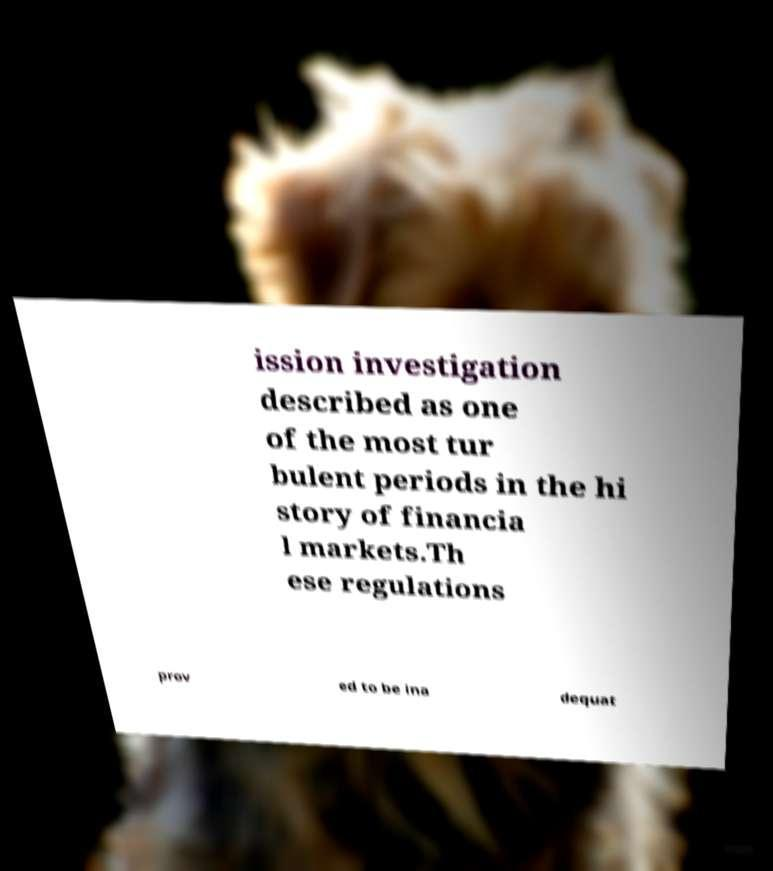Please read and relay the text visible in this image. What does it say? ission investigation described as one of the most tur bulent periods in the hi story of financia l markets.Th ese regulations prov ed to be ina dequat 